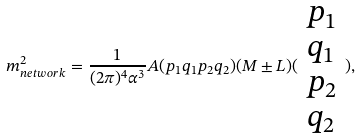Convert formula to latex. <formula><loc_0><loc_0><loc_500><loc_500>m _ { n e t w o r k } ^ { 2 } = \frac { 1 } { ( 2 \pi ) ^ { 4 } \alpha ^ { 3 } } A ( p _ { 1 } q _ { 1 } p _ { 2 } q _ { 2 } ) ( M \pm L ) ( \begin{array} { c } p _ { 1 } \\ q _ { 1 } \\ p _ { 2 } \\ q _ { 2 } \end{array} ) ,</formula> 